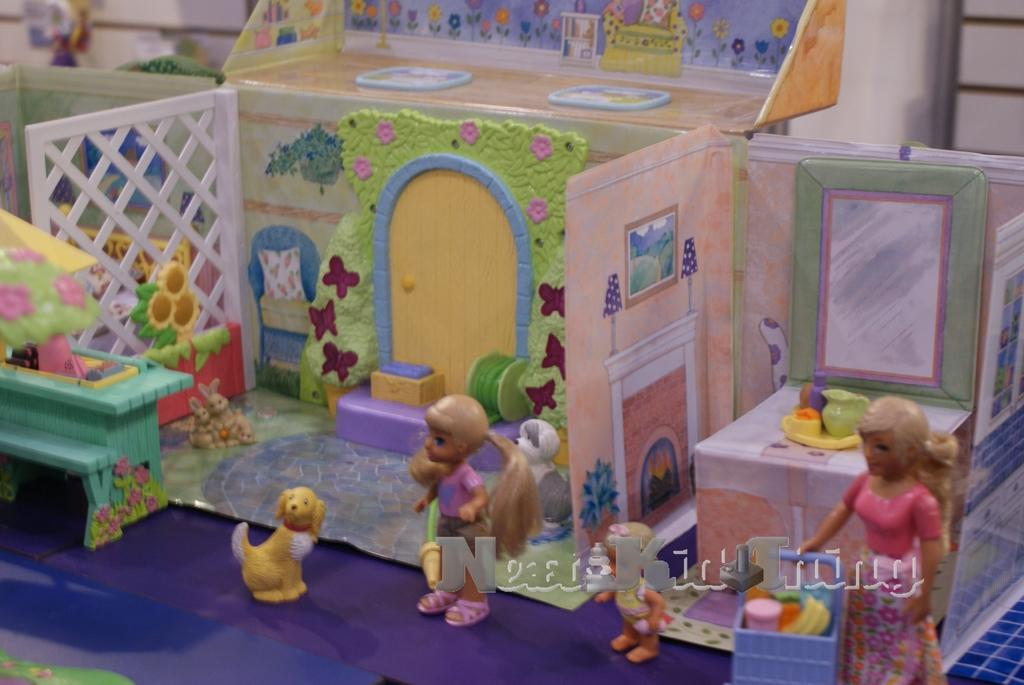What type of toy house is present in the image? There is a miniature toy house made up of cardboard in the image. What decorative elements are present on the toy house? The toy house has decorative flowers. How many dolls are in the image? There are two dolls in the image. What type of animal is present in the image? There is a yellow color small dog in the image. What appliance is being used to shake the dog in the image? There is no appliance present in the image, and the dog is not being shaken. 